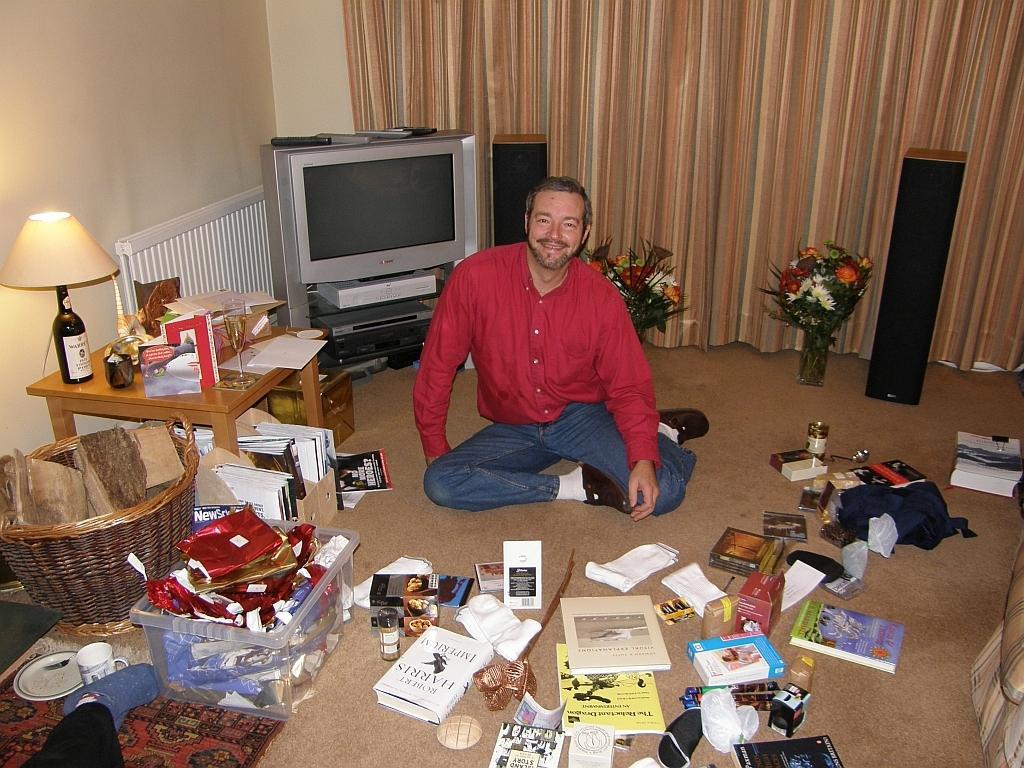Could you give a brief overview of what you see in this image? This person is sitting on a floor. On this floor there is a container, basket, bag, books and things. On this table there is a lamp, bottle and things. Backside of this person there is a television. In-front of this curtain there are speakers and flowers in vases. 